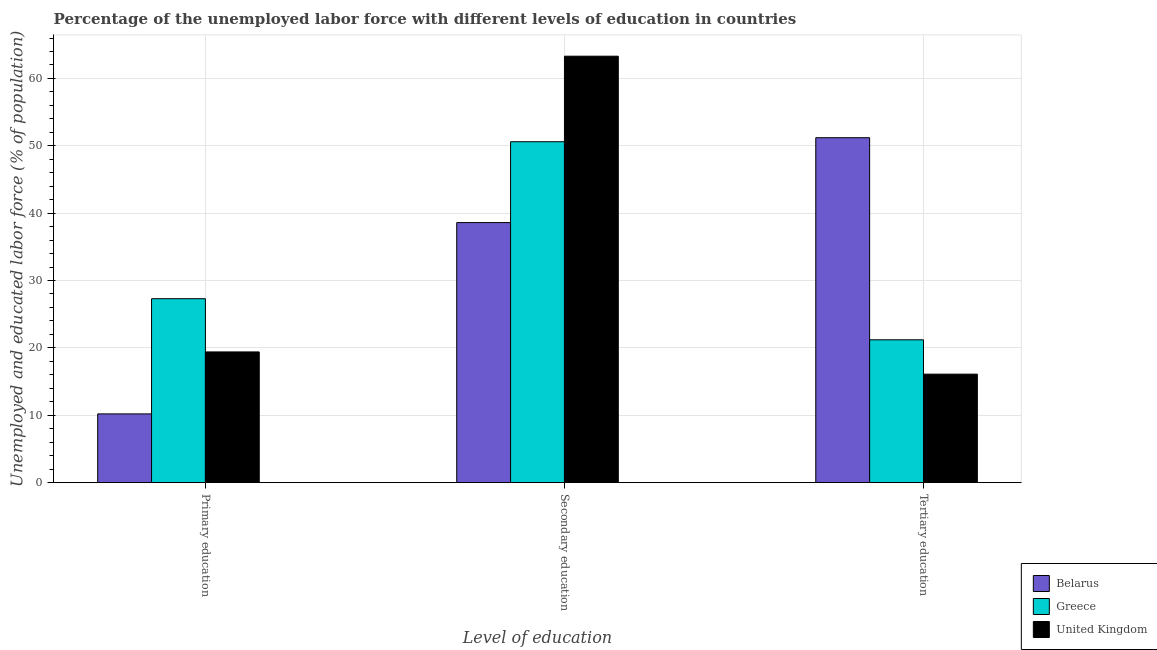How many different coloured bars are there?
Your response must be concise. 3. How many groups of bars are there?
Keep it short and to the point. 3. How many bars are there on the 2nd tick from the left?
Offer a very short reply. 3. How many bars are there on the 3rd tick from the right?
Offer a terse response. 3. What is the label of the 3rd group of bars from the left?
Offer a very short reply. Tertiary education. What is the percentage of labor force who received tertiary education in Greece?
Your answer should be compact. 21.2. Across all countries, what is the maximum percentage of labor force who received tertiary education?
Provide a succinct answer. 51.2. Across all countries, what is the minimum percentage of labor force who received tertiary education?
Your response must be concise. 16.1. In which country was the percentage of labor force who received primary education maximum?
Make the answer very short. Greece. What is the total percentage of labor force who received tertiary education in the graph?
Keep it short and to the point. 88.5. What is the difference between the percentage of labor force who received secondary education in Greece and that in United Kingdom?
Keep it short and to the point. -12.7. What is the difference between the percentage of labor force who received tertiary education in Greece and the percentage of labor force who received secondary education in United Kingdom?
Your answer should be compact. -42.1. What is the average percentage of labor force who received secondary education per country?
Give a very brief answer. 50.83. What is the difference between the percentage of labor force who received primary education and percentage of labor force who received secondary education in Belarus?
Provide a succinct answer. -28.4. In how many countries, is the percentage of labor force who received tertiary education greater than 52 %?
Ensure brevity in your answer.  0. What is the ratio of the percentage of labor force who received tertiary education in United Kingdom to that in Belarus?
Make the answer very short. 0.31. Is the percentage of labor force who received tertiary education in Belarus less than that in United Kingdom?
Ensure brevity in your answer.  No. Is the difference between the percentage of labor force who received secondary education in Greece and Belarus greater than the difference between the percentage of labor force who received primary education in Greece and Belarus?
Make the answer very short. No. What is the difference between the highest and the second highest percentage of labor force who received secondary education?
Your answer should be very brief. 12.7. What is the difference between the highest and the lowest percentage of labor force who received primary education?
Offer a terse response. 17.1. In how many countries, is the percentage of labor force who received secondary education greater than the average percentage of labor force who received secondary education taken over all countries?
Make the answer very short. 1. What does the 3rd bar from the left in Primary education represents?
Offer a very short reply. United Kingdom. What does the 3rd bar from the right in Tertiary education represents?
Give a very brief answer. Belarus. Is it the case that in every country, the sum of the percentage of labor force who received primary education and percentage of labor force who received secondary education is greater than the percentage of labor force who received tertiary education?
Offer a very short reply. No. Are all the bars in the graph horizontal?
Your response must be concise. No. What is the difference between two consecutive major ticks on the Y-axis?
Provide a succinct answer. 10. Does the graph contain grids?
Offer a terse response. Yes. Where does the legend appear in the graph?
Provide a short and direct response. Bottom right. How many legend labels are there?
Ensure brevity in your answer.  3. How are the legend labels stacked?
Your response must be concise. Vertical. What is the title of the graph?
Provide a short and direct response. Percentage of the unemployed labor force with different levels of education in countries. What is the label or title of the X-axis?
Provide a succinct answer. Level of education. What is the label or title of the Y-axis?
Your answer should be very brief. Unemployed and educated labor force (% of population). What is the Unemployed and educated labor force (% of population) in Belarus in Primary education?
Make the answer very short. 10.2. What is the Unemployed and educated labor force (% of population) of Greece in Primary education?
Provide a succinct answer. 27.3. What is the Unemployed and educated labor force (% of population) of United Kingdom in Primary education?
Ensure brevity in your answer.  19.4. What is the Unemployed and educated labor force (% of population) in Belarus in Secondary education?
Give a very brief answer. 38.6. What is the Unemployed and educated labor force (% of population) in Greece in Secondary education?
Your answer should be very brief. 50.6. What is the Unemployed and educated labor force (% of population) in United Kingdom in Secondary education?
Keep it short and to the point. 63.3. What is the Unemployed and educated labor force (% of population) of Belarus in Tertiary education?
Your response must be concise. 51.2. What is the Unemployed and educated labor force (% of population) in Greece in Tertiary education?
Give a very brief answer. 21.2. What is the Unemployed and educated labor force (% of population) in United Kingdom in Tertiary education?
Make the answer very short. 16.1. Across all Level of education, what is the maximum Unemployed and educated labor force (% of population) of Belarus?
Keep it short and to the point. 51.2. Across all Level of education, what is the maximum Unemployed and educated labor force (% of population) in Greece?
Offer a very short reply. 50.6. Across all Level of education, what is the maximum Unemployed and educated labor force (% of population) in United Kingdom?
Your answer should be very brief. 63.3. Across all Level of education, what is the minimum Unemployed and educated labor force (% of population) of Belarus?
Ensure brevity in your answer.  10.2. Across all Level of education, what is the minimum Unemployed and educated labor force (% of population) of Greece?
Offer a terse response. 21.2. Across all Level of education, what is the minimum Unemployed and educated labor force (% of population) in United Kingdom?
Provide a short and direct response. 16.1. What is the total Unemployed and educated labor force (% of population) in Belarus in the graph?
Keep it short and to the point. 100. What is the total Unemployed and educated labor force (% of population) of Greece in the graph?
Your response must be concise. 99.1. What is the total Unemployed and educated labor force (% of population) of United Kingdom in the graph?
Offer a terse response. 98.8. What is the difference between the Unemployed and educated labor force (% of population) of Belarus in Primary education and that in Secondary education?
Provide a short and direct response. -28.4. What is the difference between the Unemployed and educated labor force (% of population) of Greece in Primary education and that in Secondary education?
Your response must be concise. -23.3. What is the difference between the Unemployed and educated labor force (% of population) in United Kingdom in Primary education and that in Secondary education?
Your response must be concise. -43.9. What is the difference between the Unemployed and educated labor force (% of population) of Belarus in Primary education and that in Tertiary education?
Offer a very short reply. -41. What is the difference between the Unemployed and educated labor force (% of population) of Belarus in Secondary education and that in Tertiary education?
Offer a very short reply. -12.6. What is the difference between the Unemployed and educated labor force (% of population) in Greece in Secondary education and that in Tertiary education?
Offer a terse response. 29.4. What is the difference between the Unemployed and educated labor force (% of population) of United Kingdom in Secondary education and that in Tertiary education?
Offer a terse response. 47.2. What is the difference between the Unemployed and educated labor force (% of population) in Belarus in Primary education and the Unemployed and educated labor force (% of population) in Greece in Secondary education?
Provide a succinct answer. -40.4. What is the difference between the Unemployed and educated labor force (% of population) in Belarus in Primary education and the Unemployed and educated labor force (% of population) in United Kingdom in Secondary education?
Offer a terse response. -53.1. What is the difference between the Unemployed and educated labor force (% of population) of Greece in Primary education and the Unemployed and educated labor force (% of population) of United Kingdom in Secondary education?
Offer a very short reply. -36. What is the difference between the Unemployed and educated labor force (% of population) of Belarus in Primary education and the Unemployed and educated labor force (% of population) of United Kingdom in Tertiary education?
Offer a terse response. -5.9. What is the difference between the Unemployed and educated labor force (% of population) of Greece in Primary education and the Unemployed and educated labor force (% of population) of United Kingdom in Tertiary education?
Your response must be concise. 11.2. What is the difference between the Unemployed and educated labor force (% of population) of Belarus in Secondary education and the Unemployed and educated labor force (% of population) of United Kingdom in Tertiary education?
Keep it short and to the point. 22.5. What is the difference between the Unemployed and educated labor force (% of population) of Greece in Secondary education and the Unemployed and educated labor force (% of population) of United Kingdom in Tertiary education?
Keep it short and to the point. 34.5. What is the average Unemployed and educated labor force (% of population) of Belarus per Level of education?
Your answer should be compact. 33.33. What is the average Unemployed and educated labor force (% of population) in Greece per Level of education?
Your answer should be very brief. 33.03. What is the average Unemployed and educated labor force (% of population) in United Kingdom per Level of education?
Make the answer very short. 32.93. What is the difference between the Unemployed and educated labor force (% of population) in Belarus and Unemployed and educated labor force (% of population) in Greece in Primary education?
Your response must be concise. -17.1. What is the difference between the Unemployed and educated labor force (% of population) in Belarus and Unemployed and educated labor force (% of population) in United Kingdom in Primary education?
Provide a succinct answer. -9.2. What is the difference between the Unemployed and educated labor force (% of population) of Greece and Unemployed and educated labor force (% of population) of United Kingdom in Primary education?
Provide a succinct answer. 7.9. What is the difference between the Unemployed and educated labor force (% of population) of Belarus and Unemployed and educated labor force (% of population) of Greece in Secondary education?
Offer a terse response. -12. What is the difference between the Unemployed and educated labor force (% of population) in Belarus and Unemployed and educated labor force (% of population) in United Kingdom in Secondary education?
Give a very brief answer. -24.7. What is the difference between the Unemployed and educated labor force (% of population) in Belarus and Unemployed and educated labor force (% of population) in United Kingdom in Tertiary education?
Give a very brief answer. 35.1. What is the difference between the Unemployed and educated labor force (% of population) of Greece and Unemployed and educated labor force (% of population) of United Kingdom in Tertiary education?
Your answer should be compact. 5.1. What is the ratio of the Unemployed and educated labor force (% of population) of Belarus in Primary education to that in Secondary education?
Offer a terse response. 0.26. What is the ratio of the Unemployed and educated labor force (% of population) of Greece in Primary education to that in Secondary education?
Offer a terse response. 0.54. What is the ratio of the Unemployed and educated labor force (% of population) of United Kingdom in Primary education to that in Secondary education?
Ensure brevity in your answer.  0.31. What is the ratio of the Unemployed and educated labor force (% of population) of Belarus in Primary education to that in Tertiary education?
Ensure brevity in your answer.  0.2. What is the ratio of the Unemployed and educated labor force (% of population) in Greece in Primary education to that in Tertiary education?
Offer a terse response. 1.29. What is the ratio of the Unemployed and educated labor force (% of population) of United Kingdom in Primary education to that in Tertiary education?
Ensure brevity in your answer.  1.21. What is the ratio of the Unemployed and educated labor force (% of population) of Belarus in Secondary education to that in Tertiary education?
Keep it short and to the point. 0.75. What is the ratio of the Unemployed and educated labor force (% of population) in Greece in Secondary education to that in Tertiary education?
Make the answer very short. 2.39. What is the ratio of the Unemployed and educated labor force (% of population) in United Kingdom in Secondary education to that in Tertiary education?
Your answer should be very brief. 3.93. What is the difference between the highest and the second highest Unemployed and educated labor force (% of population) in Greece?
Offer a very short reply. 23.3. What is the difference between the highest and the second highest Unemployed and educated labor force (% of population) of United Kingdom?
Your answer should be very brief. 43.9. What is the difference between the highest and the lowest Unemployed and educated labor force (% of population) of Belarus?
Offer a terse response. 41. What is the difference between the highest and the lowest Unemployed and educated labor force (% of population) of Greece?
Provide a succinct answer. 29.4. What is the difference between the highest and the lowest Unemployed and educated labor force (% of population) of United Kingdom?
Ensure brevity in your answer.  47.2. 